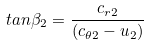<formula> <loc_0><loc_0><loc_500><loc_500>t a n \beta _ { 2 } = \frac { c _ { r 2 } } { ( c _ { \theta 2 } - u _ { 2 } ) }</formula> 